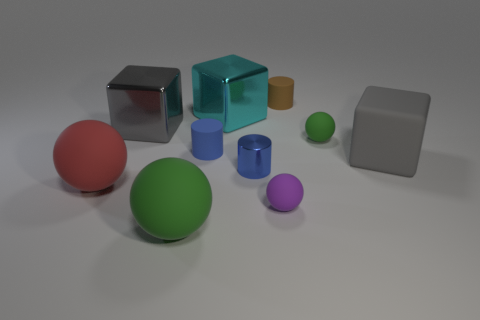Subtract 3 cubes. How many cubes are left? 0 Subtract all rubber cubes. How many cubes are left? 2 Subtract all blocks. How many objects are left? 7 Subtract all yellow cubes. How many blue cylinders are left? 2 Subtract all tiny green rubber spheres. Subtract all big gray matte things. How many objects are left? 8 Add 8 red rubber spheres. How many red rubber spheres are left? 9 Add 8 large metallic things. How many large metallic things exist? 10 Subtract all blue cylinders. How many cylinders are left? 1 Subtract 0 green cubes. How many objects are left? 10 Subtract all brown cubes. Subtract all green spheres. How many cubes are left? 3 